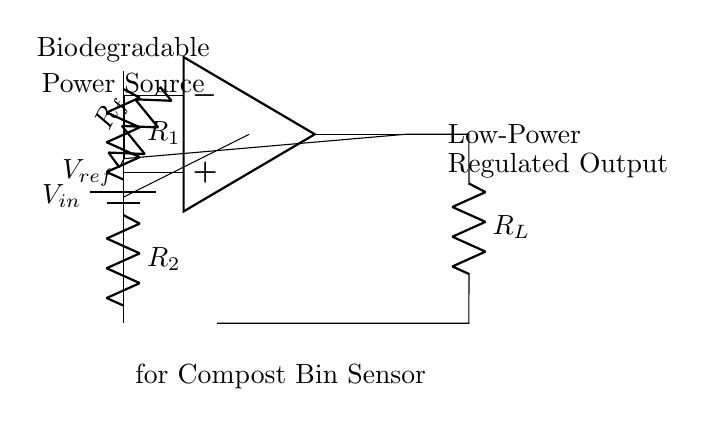What is the power source in this circuit? The power source is represented by the battery symbol on the left side of the circuit diagram, labeled as Vin.
Answer: Vin What components are used in the voltage divider? The voltage divider consists of two resistors labeled as R1 and R2, which are connected in series.
Answer: R1 and R2 What is the output of the op-amp? The output of the op-amp is connected to a resistor labeled R_L, indicating it supplies the load with a regulated output voltage.
Answer: Regulated Output What role does R_f play in the circuit? R_f is part of the feedback network to the op-amp, helping determine the gain and stability of the output regulation.
Answer: Feedback Resistor How does the feedback network affect the output? The feedback network provides a pathway for the output voltage to influence the input at the inverting terminal of the op-amp, allowing it to stabilize and regulate the voltage. This helps maintain a constant output voltage despite changes in input voltage or load conditions.
Answer: Stabilizes Output What type of regulator is shown in the circuit? The circuit diagram represents a low-power linear regulator designed for compact and efficient voltage regulation, suitable for sensors.
Answer: Low-Power Linear Regulator What is the purpose of the biodegradable power source noted in the circuit? The biodegradable power source is designed to minimize environmental impact, which aligns with the objectives of using biodegradable sensors in compost bins for sustainable waste management.
Answer: Biodegradable Energy Source 